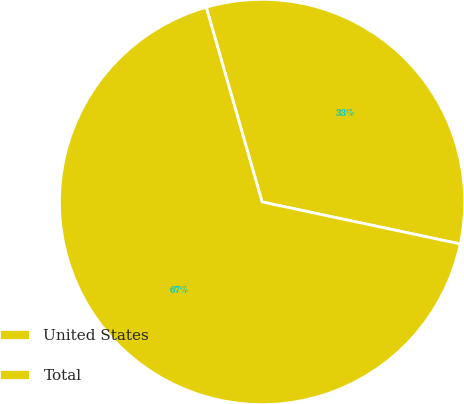<chart> <loc_0><loc_0><loc_500><loc_500><pie_chart><fcel>United States<fcel>Total<nl><fcel>32.77%<fcel>67.23%<nl></chart> 